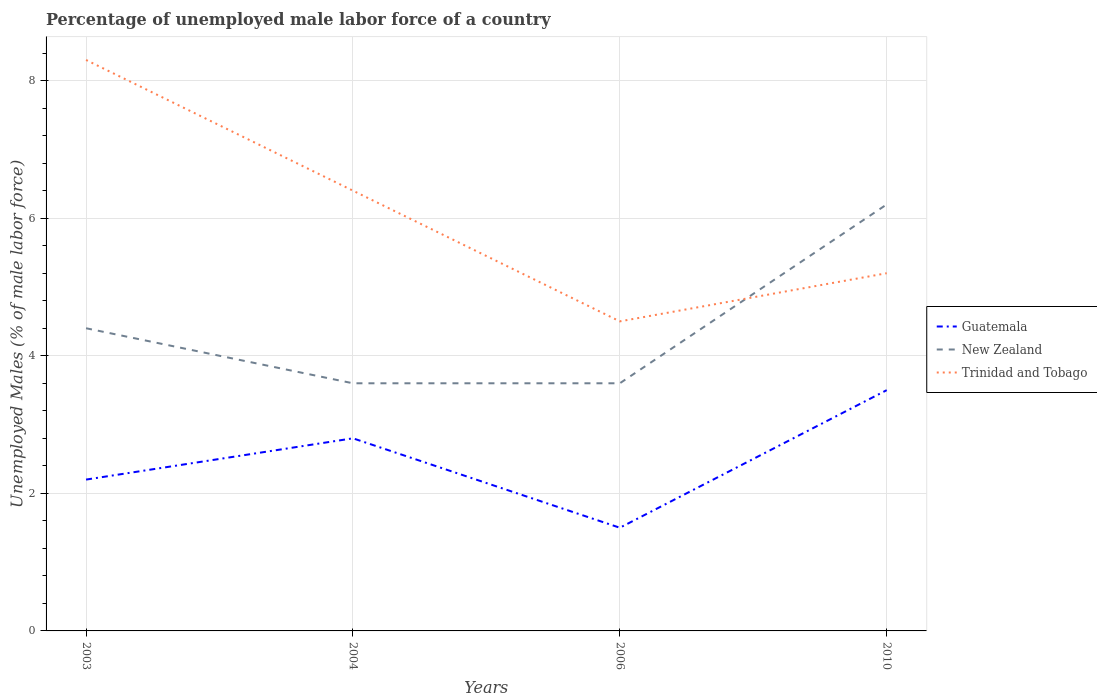How many different coloured lines are there?
Your answer should be compact. 3. Across all years, what is the maximum percentage of unemployed male labor force in New Zealand?
Your response must be concise. 3.6. What is the total percentage of unemployed male labor force in Guatemala in the graph?
Your answer should be very brief. -2. Is the percentage of unemployed male labor force in Trinidad and Tobago strictly greater than the percentage of unemployed male labor force in New Zealand over the years?
Give a very brief answer. No. Does the graph contain any zero values?
Offer a terse response. No. Does the graph contain grids?
Provide a succinct answer. Yes. Where does the legend appear in the graph?
Provide a short and direct response. Center right. How many legend labels are there?
Offer a very short reply. 3. What is the title of the graph?
Ensure brevity in your answer.  Percentage of unemployed male labor force of a country. What is the label or title of the X-axis?
Your answer should be compact. Years. What is the label or title of the Y-axis?
Ensure brevity in your answer.  Unemployed Males (% of male labor force). What is the Unemployed Males (% of male labor force) of Guatemala in 2003?
Offer a terse response. 2.2. What is the Unemployed Males (% of male labor force) in New Zealand in 2003?
Ensure brevity in your answer.  4.4. What is the Unemployed Males (% of male labor force) in Trinidad and Tobago in 2003?
Your answer should be compact. 8.3. What is the Unemployed Males (% of male labor force) in Guatemala in 2004?
Offer a terse response. 2.8. What is the Unemployed Males (% of male labor force) in New Zealand in 2004?
Ensure brevity in your answer.  3.6. What is the Unemployed Males (% of male labor force) of Trinidad and Tobago in 2004?
Your answer should be compact. 6.4. What is the Unemployed Males (% of male labor force) of New Zealand in 2006?
Ensure brevity in your answer.  3.6. What is the Unemployed Males (% of male labor force) in Guatemala in 2010?
Provide a succinct answer. 3.5. What is the Unemployed Males (% of male labor force) in New Zealand in 2010?
Ensure brevity in your answer.  6.2. What is the Unemployed Males (% of male labor force) of Trinidad and Tobago in 2010?
Make the answer very short. 5.2. Across all years, what is the maximum Unemployed Males (% of male labor force) in Guatemala?
Ensure brevity in your answer.  3.5. Across all years, what is the maximum Unemployed Males (% of male labor force) in New Zealand?
Your answer should be compact. 6.2. Across all years, what is the maximum Unemployed Males (% of male labor force) in Trinidad and Tobago?
Your response must be concise. 8.3. Across all years, what is the minimum Unemployed Males (% of male labor force) in New Zealand?
Give a very brief answer. 3.6. Across all years, what is the minimum Unemployed Males (% of male labor force) of Trinidad and Tobago?
Your answer should be very brief. 4.5. What is the total Unemployed Males (% of male labor force) of Guatemala in the graph?
Provide a short and direct response. 10. What is the total Unemployed Males (% of male labor force) in Trinidad and Tobago in the graph?
Keep it short and to the point. 24.4. What is the difference between the Unemployed Males (% of male labor force) in New Zealand in 2003 and that in 2004?
Keep it short and to the point. 0.8. What is the difference between the Unemployed Males (% of male labor force) of Trinidad and Tobago in 2003 and that in 2004?
Make the answer very short. 1.9. What is the difference between the Unemployed Males (% of male labor force) of New Zealand in 2003 and that in 2006?
Your answer should be very brief. 0.8. What is the difference between the Unemployed Males (% of male labor force) of Trinidad and Tobago in 2003 and that in 2006?
Offer a terse response. 3.8. What is the difference between the Unemployed Males (% of male labor force) of Guatemala in 2003 and that in 2010?
Your answer should be very brief. -1.3. What is the difference between the Unemployed Males (% of male labor force) in New Zealand in 2003 and that in 2010?
Provide a succinct answer. -1.8. What is the difference between the Unemployed Males (% of male labor force) in New Zealand in 2004 and that in 2006?
Provide a short and direct response. 0. What is the difference between the Unemployed Males (% of male labor force) in Trinidad and Tobago in 2004 and that in 2006?
Your answer should be compact. 1.9. What is the difference between the Unemployed Males (% of male labor force) of Guatemala in 2006 and that in 2010?
Offer a terse response. -2. What is the difference between the Unemployed Males (% of male labor force) of Trinidad and Tobago in 2006 and that in 2010?
Provide a succinct answer. -0.7. What is the difference between the Unemployed Males (% of male labor force) in Guatemala in 2003 and the Unemployed Males (% of male labor force) in New Zealand in 2004?
Provide a short and direct response. -1.4. What is the difference between the Unemployed Males (% of male labor force) of Guatemala in 2003 and the Unemployed Males (% of male labor force) of Trinidad and Tobago in 2004?
Give a very brief answer. -4.2. What is the difference between the Unemployed Males (% of male labor force) of New Zealand in 2003 and the Unemployed Males (% of male labor force) of Trinidad and Tobago in 2004?
Make the answer very short. -2. What is the difference between the Unemployed Males (% of male labor force) in Guatemala in 2003 and the Unemployed Males (% of male labor force) in Trinidad and Tobago in 2010?
Offer a very short reply. -3. What is the difference between the Unemployed Males (% of male labor force) in Guatemala in 2004 and the Unemployed Males (% of male labor force) in Trinidad and Tobago in 2006?
Ensure brevity in your answer.  -1.7. What is the difference between the Unemployed Males (% of male labor force) of Guatemala in 2004 and the Unemployed Males (% of male labor force) of New Zealand in 2010?
Your response must be concise. -3.4. What is the difference between the Unemployed Males (% of male labor force) in New Zealand in 2004 and the Unemployed Males (% of male labor force) in Trinidad and Tobago in 2010?
Ensure brevity in your answer.  -1.6. What is the difference between the Unemployed Males (% of male labor force) in New Zealand in 2006 and the Unemployed Males (% of male labor force) in Trinidad and Tobago in 2010?
Make the answer very short. -1.6. What is the average Unemployed Males (% of male labor force) in Guatemala per year?
Your response must be concise. 2.5. What is the average Unemployed Males (% of male labor force) in New Zealand per year?
Provide a succinct answer. 4.45. What is the average Unemployed Males (% of male labor force) of Trinidad and Tobago per year?
Your answer should be compact. 6.1. In the year 2003, what is the difference between the Unemployed Males (% of male labor force) in Guatemala and Unemployed Males (% of male labor force) in New Zealand?
Keep it short and to the point. -2.2. In the year 2003, what is the difference between the Unemployed Males (% of male labor force) of New Zealand and Unemployed Males (% of male labor force) of Trinidad and Tobago?
Ensure brevity in your answer.  -3.9. In the year 2006, what is the difference between the Unemployed Males (% of male labor force) of Guatemala and Unemployed Males (% of male labor force) of Trinidad and Tobago?
Offer a very short reply. -3. In the year 2006, what is the difference between the Unemployed Males (% of male labor force) in New Zealand and Unemployed Males (% of male labor force) in Trinidad and Tobago?
Offer a terse response. -0.9. In the year 2010, what is the difference between the Unemployed Males (% of male labor force) of New Zealand and Unemployed Males (% of male labor force) of Trinidad and Tobago?
Make the answer very short. 1. What is the ratio of the Unemployed Males (% of male labor force) of Guatemala in 2003 to that in 2004?
Your response must be concise. 0.79. What is the ratio of the Unemployed Males (% of male labor force) in New Zealand in 2003 to that in 2004?
Your answer should be very brief. 1.22. What is the ratio of the Unemployed Males (% of male labor force) in Trinidad and Tobago in 2003 to that in 2004?
Provide a short and direct response. 1.3. What is the ratio of the Unemployed Males (% of male labor force) in Guatemala in 2003 to that in 2006?
Your response must be concise. 1.47. What is the ratio of the Unemployed Males (% of male labor force) in New Zealand in 2003 to that in 2006?
Offer a very short reply. 1.22. What is the ratio of the Unemployed Males (% of male labor force) in Trinidad and Tobago in 2003 to that in 2006?
Give a very brief answer. 1.84. What is the ratio of the Unemployed Males (% of male labor force) of Guatemala in 2003 to that in 2010?
Offer a very short reply. 0.63. What is the ratio of the Unemployed Males (% of male labor force) in New Zealand in 2003 to that in 2010?
Provide a succinct answer. 0.71. What is the ratio of the Unemployed Males (% of male labor force) of Trinidad and Tobago in 2003 to that in 2010?
Your answer should be very brief. 1.6. What is the ratio of the Unemployed Males (% of male labor force) in Guatemala in 2004 to that in 2006?
Offer a terse response. 1.87. What is the ratio of the Unemployed Males (% of male labor force) of New Zealand in 2004 to that in 2006?
Provide a short and direct response. 1. What is the ratio of the Unemployed Males (% of male labor force) of Trinidad and Tobago in 2004 to that in 2006?
Provide a succinct answer. 1.42. What is the ratio of the Unemployed Males (% of male labor force) of New Zealand in 2004 to that in 2010?
Offer a very short reply. 0.58. What is the ratio of the Unemployed Males (% of male labor force) of Trinidad and Tobago in 2004 to that in 2010?
Your answer should be compact. 1.23. What is the ratio of the Unemployed Males (% of male labor force) of Guatemala in 2006 to that in 2010?
Keep it short and to the point. 0.43. What is the ratio of the Unemployed Males (% of male labor force) in New Zealand in 2006 to that in 2010?
Your response must be concise. 0.58. What is the ratio of the Unemployed Males (% of male labor force) in Trinidad and Tobago in 2006 to that in 2010?
Make the answer very short. 0.87. What is the difference between the highest and the second highest Unemployed Males (% of male labor force) in Guatemala?
Make the answer very short. 0.7. What is the difference between the highest and the second highest Unemployed Males (% of male labor force) in New Zealand?
Ensure brevity in your answer.  1.8. What is the difference between the highest and the second highest Unemployed Males (% of male labor force) in Trinidad and Tobago?
Your answer should be compact. 1.9. What is the difference between the highest and the lowest Unemployed Males (% of male labor force) in Guatemala?
Provide a succinct answer. 2. What is the difference between the highest and the lowest Unemployed Males (% of male labor force) in New Zealand?
Ensure brevity in your answer.  2.6. What is the difference between the highest and the lowest Unemployed Males (% of male labor force) in Trinidad and Tobago?
Your answer should be compact. 3.8. 